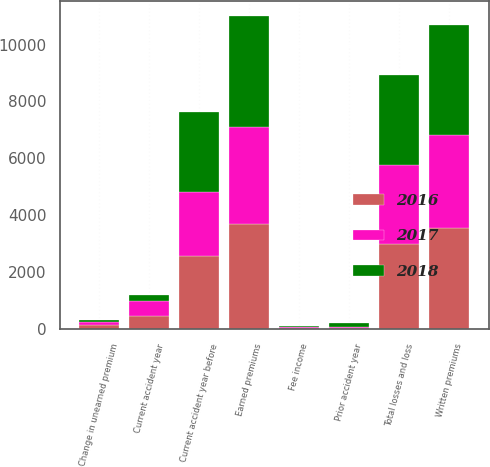Convert chart. <chart><loc_0><loc_0><loc_500><loc_500><stacked_bar_chart><ecel><fcel>Written premiums<fcel>Change in unearned premium<fcel>Earned premiums<fcel>Fee income<fcel>Current accident year before<fcel>Current accident year<fcel>Prior accident year<fcel>Total losses and loss<nl><fcel>2017<fcel>3276<fcel>123<fcel>3399<fcel>40<fcel>2249<fcel>546<fcel>32<fcel>2763<nl><fcel>2016<fcel>3561<fcel>129<fcel>3690<fcel>44<fcel>2584<fcel>453<fcel>37<fcel>3000<nl><fcel>2018<fcel>3837<fcel>61<fcel>3898<fcel>39<fcel>2808<fcel>216<fcel>151<fcel>3175<nl></chart> 